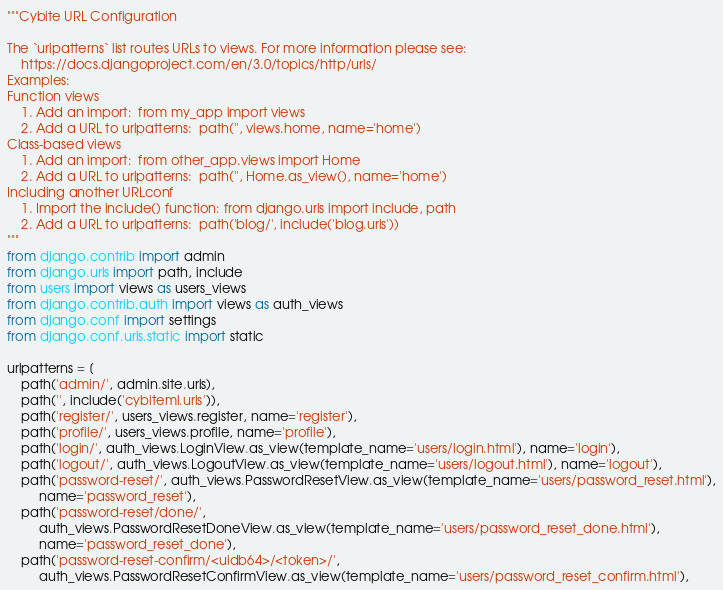<code> <loc_0><loc_0><loc_500><loc_500><_Python_>"""Cybite URL Configuration

The `urlpatterns` list routes URLs to views. For more information please see:
    https://docs.djangoproject.com/en/3.0/topics/http/urls/
Examples:
Function views
    1. Add an import:  from my_app import views
    2. Add a URL to urlpatterns:  path('', views.home, name='home')
Class-based views
    1. Add an import:  from other_app.views import Home
    2. Add a URL to urlpatterns:  path('', Home.as_view(), name='home')
Including another URLconf
    1. Import the include() function: from django.urls import include, path
    2. Add a URL to urlpatterns:  path('blog/', include('blog.urls'))
"""
from django.contrib import admin
from django.urls import path, include
from users import views as users_views
from django.contrib.auth import views as auth_views
from django.conf import settings
from django.conf.urls.static import static

urlpatterns = [
    path('admin/', admin.site.urls),
    path('', include('cybiteml.urls')),
    path('register/', users_views.register, name='register'),
    path('profile/', users_views.profile, name='profile'),
    path('login/', auth_views.LoginView.as_view(template_name='users/login.html'), name='login'),
    path('logout/', auth_views.LogoutView.as_view(template_name='users/logout.html'), name='logout'),
    path('password-reset/', auth_views.PasswordResetView.as_view(template_name='users/password_reset.html'),
         name='password_reset'),
    path('password-reset/done/',
         auth_views.PasswordResetDoneView.as_view(template_name='users/password_reset_done.html'),
         name='password_reset_done'),
    path('password-reset-confirm/<uidb64>/<token>/',
         auth_views.PasswordResetConfirmView.as_view(template_name='users/password_reset_confirm.html'),</code> 